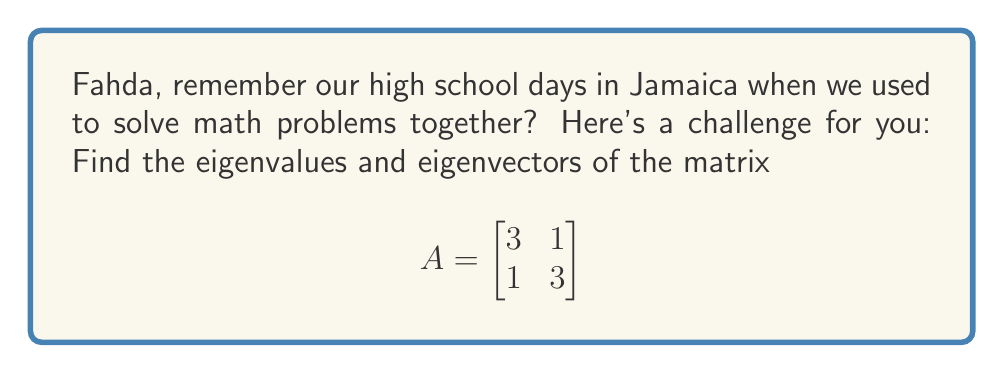Can you solve this math problem? To find the eigenvalues and eigenvectors of matrix A, we'll follow these steps:

1) First, let's find the eigenvalues by solving the characteristic equation:
   
   $det(A - \lambda I) = 0$

   where $\lambda$ represents the eigenvalues and I is the 2x2 identity matrix.

2) Expand the determinant:

   $$det\begin{bmatrix}
   3-\lambda & 1 \\
   1 & 3-\lambda
   \end{bmatrix} = 0$$

   $(3-\lambda)(3-\lambda) - 1 = 0$

3) Simplify:

   $$(3-\lambda)^2 - 1 = 0$$
   $9 - 6\lambda + \lambda^2 - 1 = 0$
   $\lambda^2 - 6\lambda + 8 = 0$

4) Solve this quadratic equation:

   $(\lambda - 4)(\lambda - 2) = 0$

   So, the eigenvalues are $\lambda_1 = 4$ and $\lambda_2 = 2$

5) Now, let's find the eigenvectors for each eigenvalue:

   For $\lambda_1 = 4$:
   
   $$(A - 4I)\vec{v} = \vec{0}$$
   
   $$\begin{bmatrix}
   -1 & 1 \\
   1 & -1
   \end{bmatrix}\begin{bmatrix}
   v_1 \\ v_2
   \end{bmatrix} = \begin{bmatrix}
   0 \\ 0
   \end{bmatrix}$$

   This gives us: $-v_1 + v_2 = 0$, or $v_1 = v_2$
   
   So, an eigenvector for $\lambda_1 = 4$ is $\vec{v_1} = \begin{bmatrix} 1 \\ 1 \end{bmatrix}$

   For $\lambda_2 = 2$:
   
   $$(A - 2I)\vec{v} = \vec{0}$$
   
   $$\begin{bmatrix}
   1 & 1 \\
   1 & 1
   \end{bmatrix}\begin{bmatrix}
   v_1 \\ v_2
   \end{bmatrix} = \begin{bmatrix}
   0 \\ 0
   \end{bmatrix}$$

   This gives us: $v_1 + v_2 = 0$, or $v_2 = -v_1$
   
   So, an eigenvector for $\lambda_2 = 2$ is $\vec{v_2} = \begin{bmatrix} 1 \\ -1 \end{bmatrix}$
Answer: Eigenvalues: $\lambda_1 = 4$, $\lambda_2 = 2$

Eigenvectors: $\vec{v_1} = \begin{bmatrix} 1 \\ 1 \end{bmatrix}$ (for $\lambda_1 = 4$), $\vec{v_2} = \begin{bmatrix} 1 \\ -1 \end{bmatrix}$ (for $\lambda_2 = 2$) 